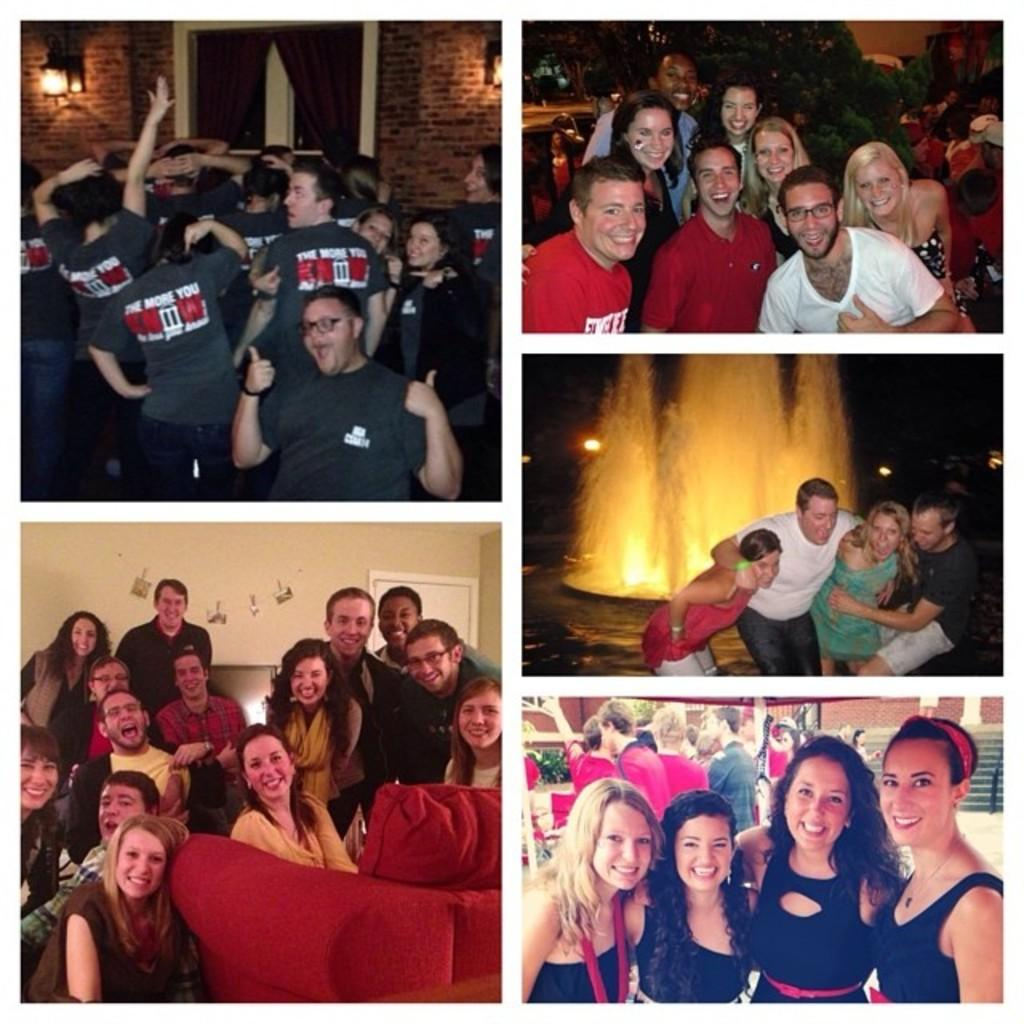What is the composition of the image? The image is a collage containing five images. What is happening in each of the images? In each image, there is a crowd of people. How are the people in the images feeling? The people in the images are smiling. What are the people in the images doing? The people in the images are giving poses for pictures. What type of bread can be seen in the image? There is no bread present in the image; it contains only crowds of people giving poses for pictures. 